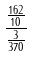Convert formula to latex. <formula><loc_0><loc_0><loc_500><loc_500>\frac { \frac { 1 6 2 } { 1 0 } } { \frac { 3 } { 3 7 0 } }</formula> 